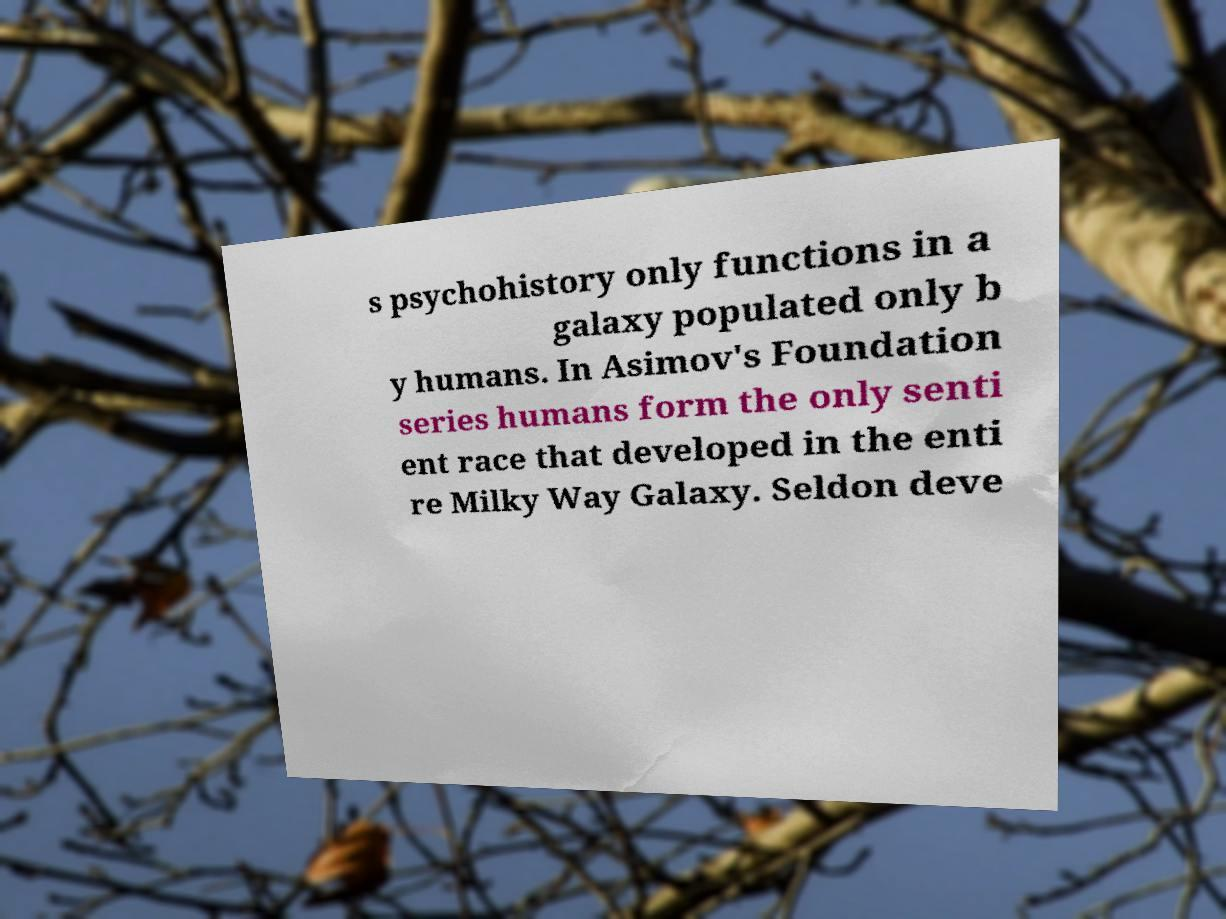Could you assist in decoding the text presented in this image and type it out clearly? s psychohistory only functions in a galaxy populated only b y humans. In Asimov's Foundation series humans form the only senti ent race that developed in the enti re Milky Way Galaxy. Seldon deve 